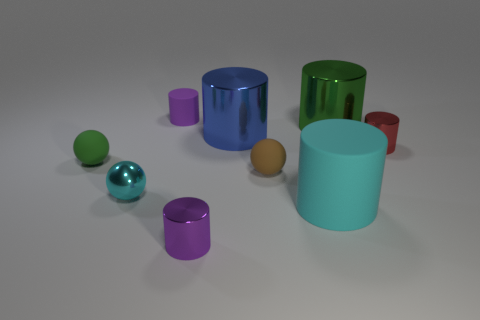What is the size of the rubber object that is the same color as the metallic sphere?
Offer a terse response. Large. Is the large rubber object the same color as the metallic sphere?
Offer a very short reply. Yes. Is there anything else of the same color as the small matte cylinder?
Keep it short and to the point. Yes. Is the number of cyan objects behind the purple matte thing less than the number of tiny green things?
Make the answer very short. Yes. Is the number of tiny metallic objects greater than the number of shiny things?
Your response must be concise. No. There is a cyan object that is to the left of the small shiny cylinder that is left of the small red thing; are there any small red metal objects that are to the left of it?
Your response must be concise. No. How many other objects are there of the same size as the green ball?
Provide a short and direct response. 5. Are there any red cylinders in front of the large cyan cylinder?
Offer a terse response. No. There is a big matte object; does it have the same color as the sphere that is in front of the tiny brown sphere?
Offer a terse response. Yes. The large object in front of the tiny shiny cylinder that is behind the small rubber sphere that is on the left side of the tiny purple rubber cylinder is what color?
Give a very brief answer. Cyan. 